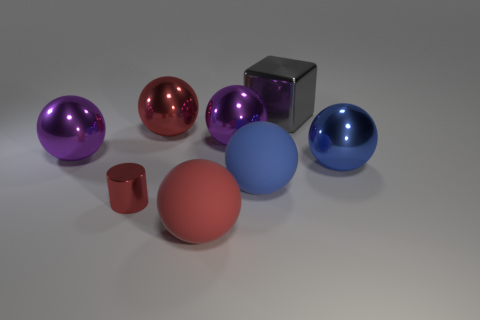Subtract all matte spheres. How many spheres are left? 4 Subtract all blue spheres. How many spheres are left? 4 Add 1 blocks. How many objects exist? 9 Subtract all cylinders. How many objects are left? 7 Subtract 0 red cubes. How many objects are left? 8 Subtract 1 cylinders. How many cylinders are left? 0 Subtract all red blocks. Subtract all blue spheres. How many blocks are left? 1 Subtract all green balls. How many gray cylinders are left? 0 Subtract all small brown metallic objects. Subtract all big objects. How many objects are left? 1 Add 3 large red spheres. How many large red spheres are left? 5 